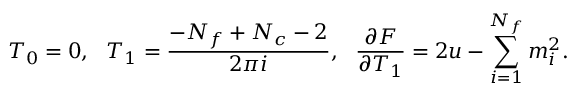Convert formula to latex. <formula><loc_0><loc_0><loc_500><loc_500>T _ { 0 } = 0 , \ \ T _ { 1 } = \frac { - N _ { f } + N _ { c } - 2 } { 2 \pi i } , \quad f r a c { \partial F } { \partial T _ { 1 } } = 2 u - \sum _ { i = 1 } ^ { N _ { f } } m _ { i } ^ { 2 } .</formula> 